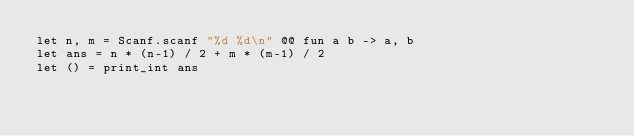Convert code to text. <code><loc_0><loc_0><loc_500><loc_500><_OCaml_>let n, m = Scanf.scanf "%d %d\n" @@ fun a b -> a, b
let ans = n * (n-1) / 2 + m * (m-1) / 2
let () = print_int ans</code> 